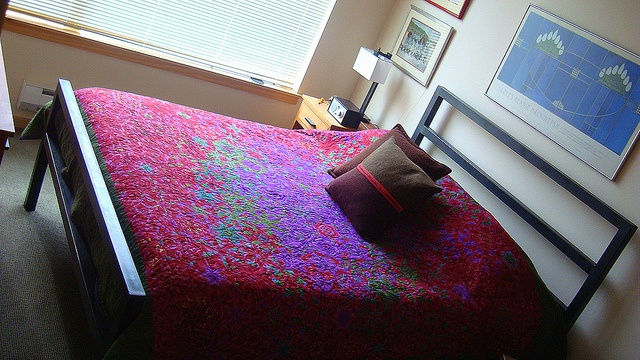Describe the objects in this image and their specific colors. I can see a bed in black, maroon, and violet tones in this image. 